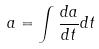Convert formula to latex. <formula><loc_0><loc_0><loc_500><loc_500>a = \int \frac { d a } { d t } d t</formula> 